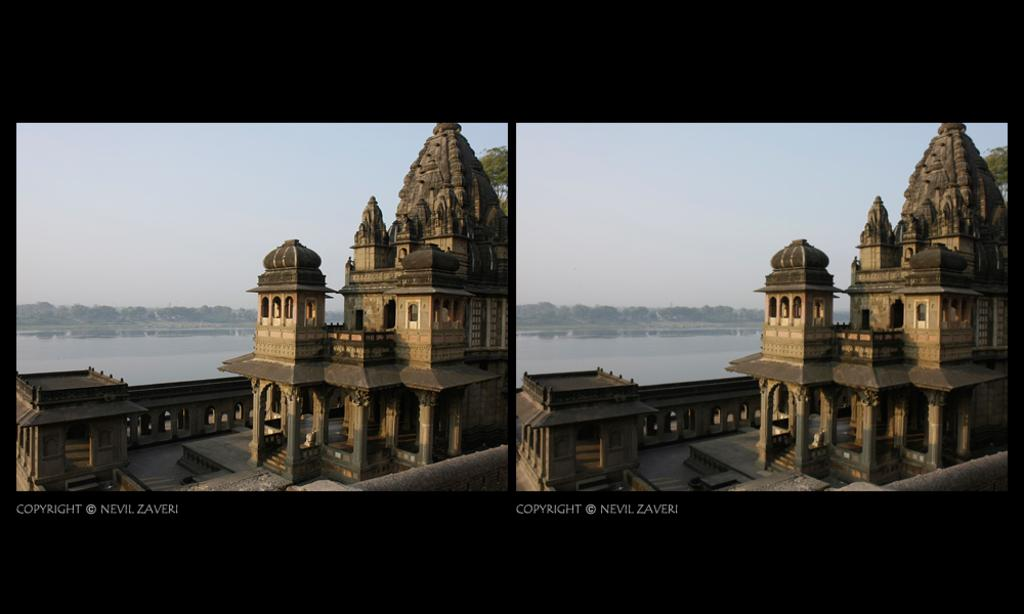What type of structure is visible on the right side of the image? There is a temple on the right side of the image. How is the temple presented in the image? The image appears to be a collage of the temple. What type of juice can be seen being poured from a cent in the image? There is no juice or cent present in the image; it only features a temple collage. 